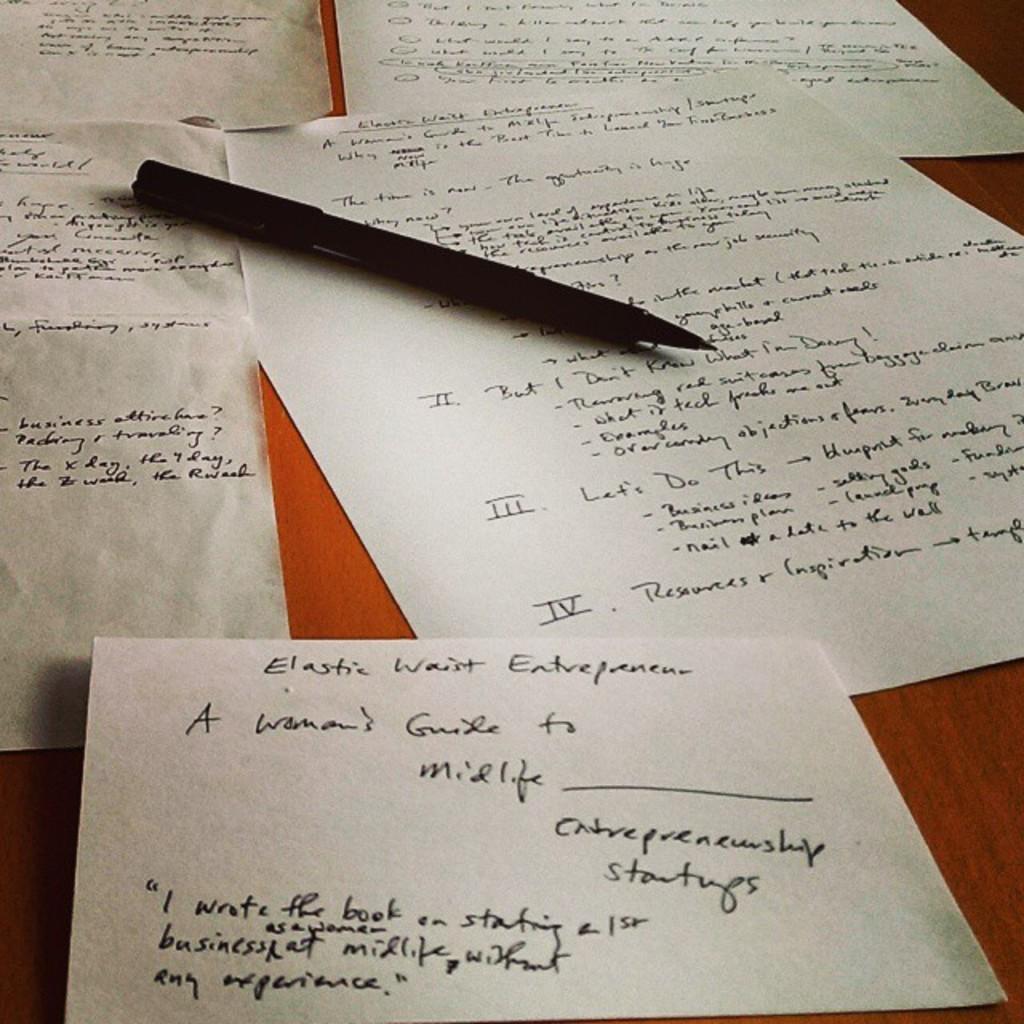In one or two sentences, can you explain what this image depicts? In this image we can see the text papers and also the pen. In the background we can see the wooden surface. 